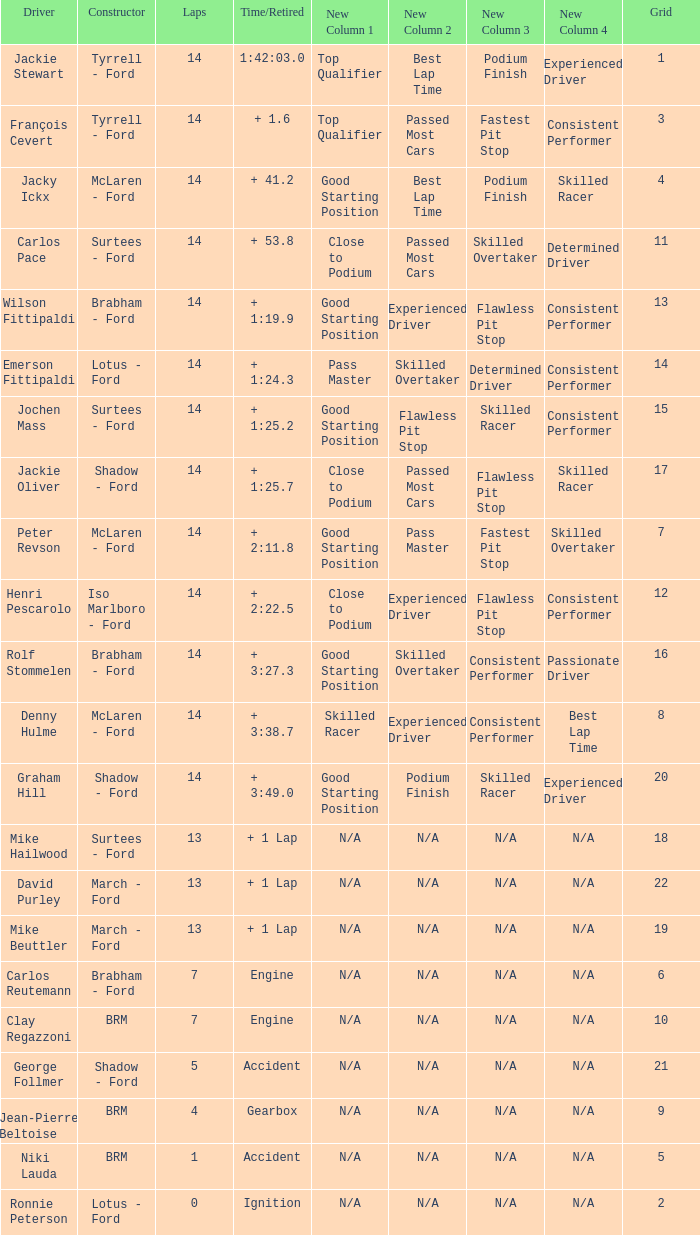What is the low lap total for a grid larger than 16 and has a Time/Retired of + 3:27.3? None. 